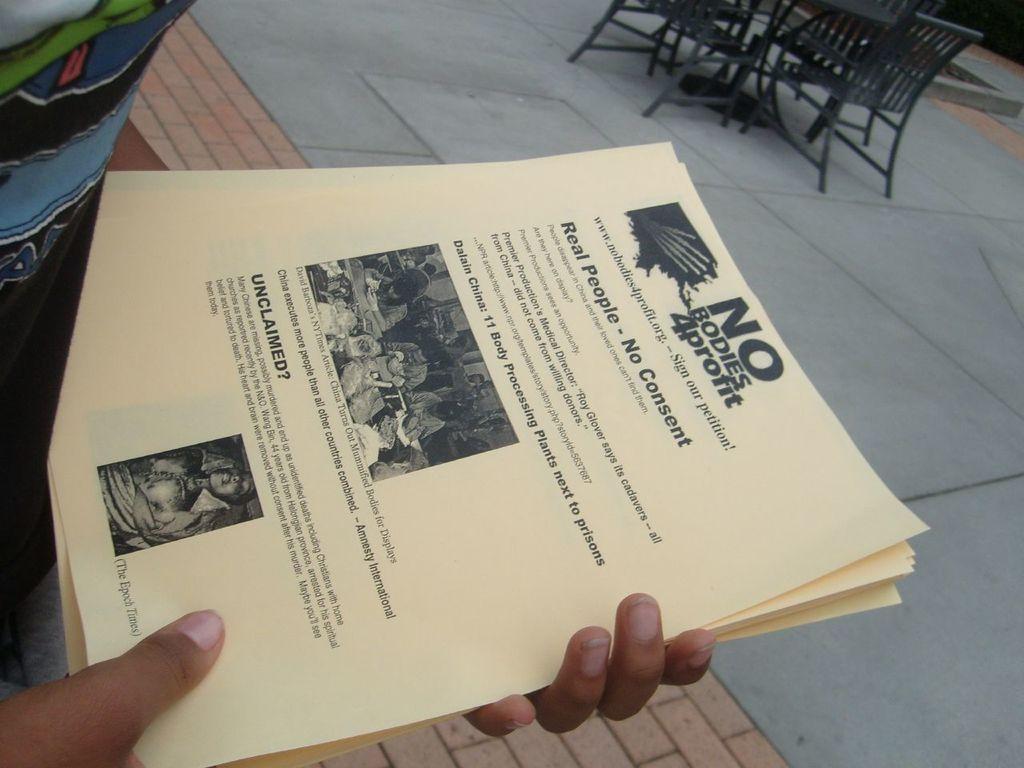Can you describe this image briefly? This image consists of a person holding the papers. At the bottom, there is a road. On the right, we can see the chairs. 